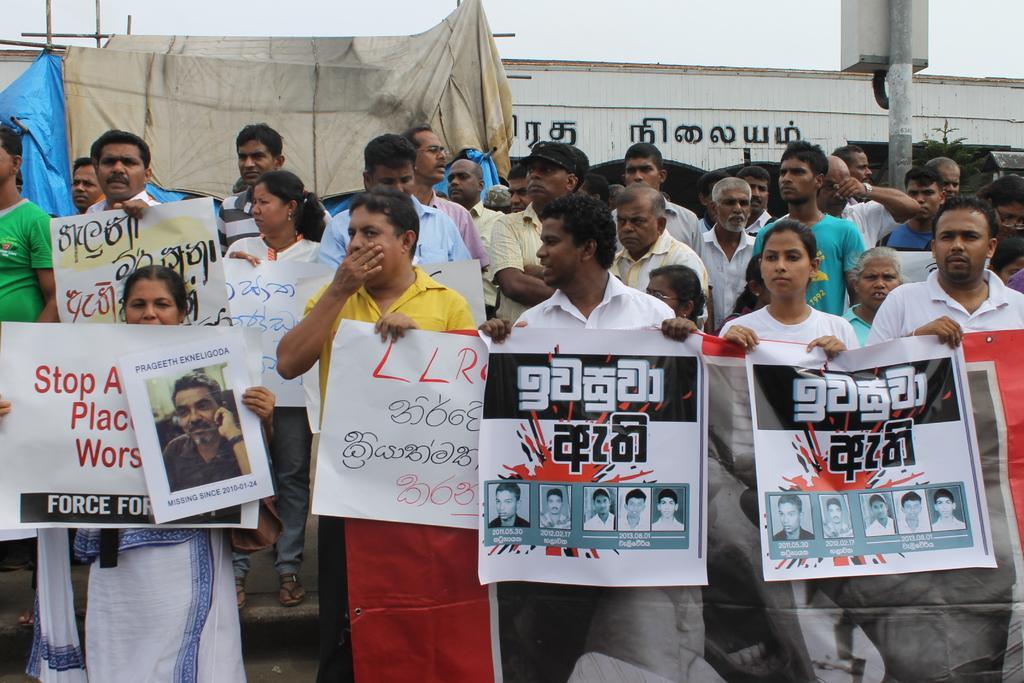Can you describe this image briefly? In this image, we can see a group of people. Few people are holding banners. Background we can see pole, box, wooden sticks, cloth, blue sheet, wall, tree and sky. 